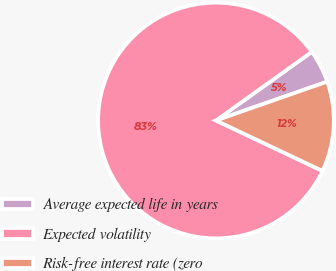Convert chart to OTSL. <chart><loc_0><loc_0><loc_500><loc_500><pie_chart><fcel>Average expected life in years<fcel>Expected volatility<fcel>Risk-free interest rate (zero<nl><fcel>4.54%<fcel>83.06%<fcel>12.39%<nl></chart> 